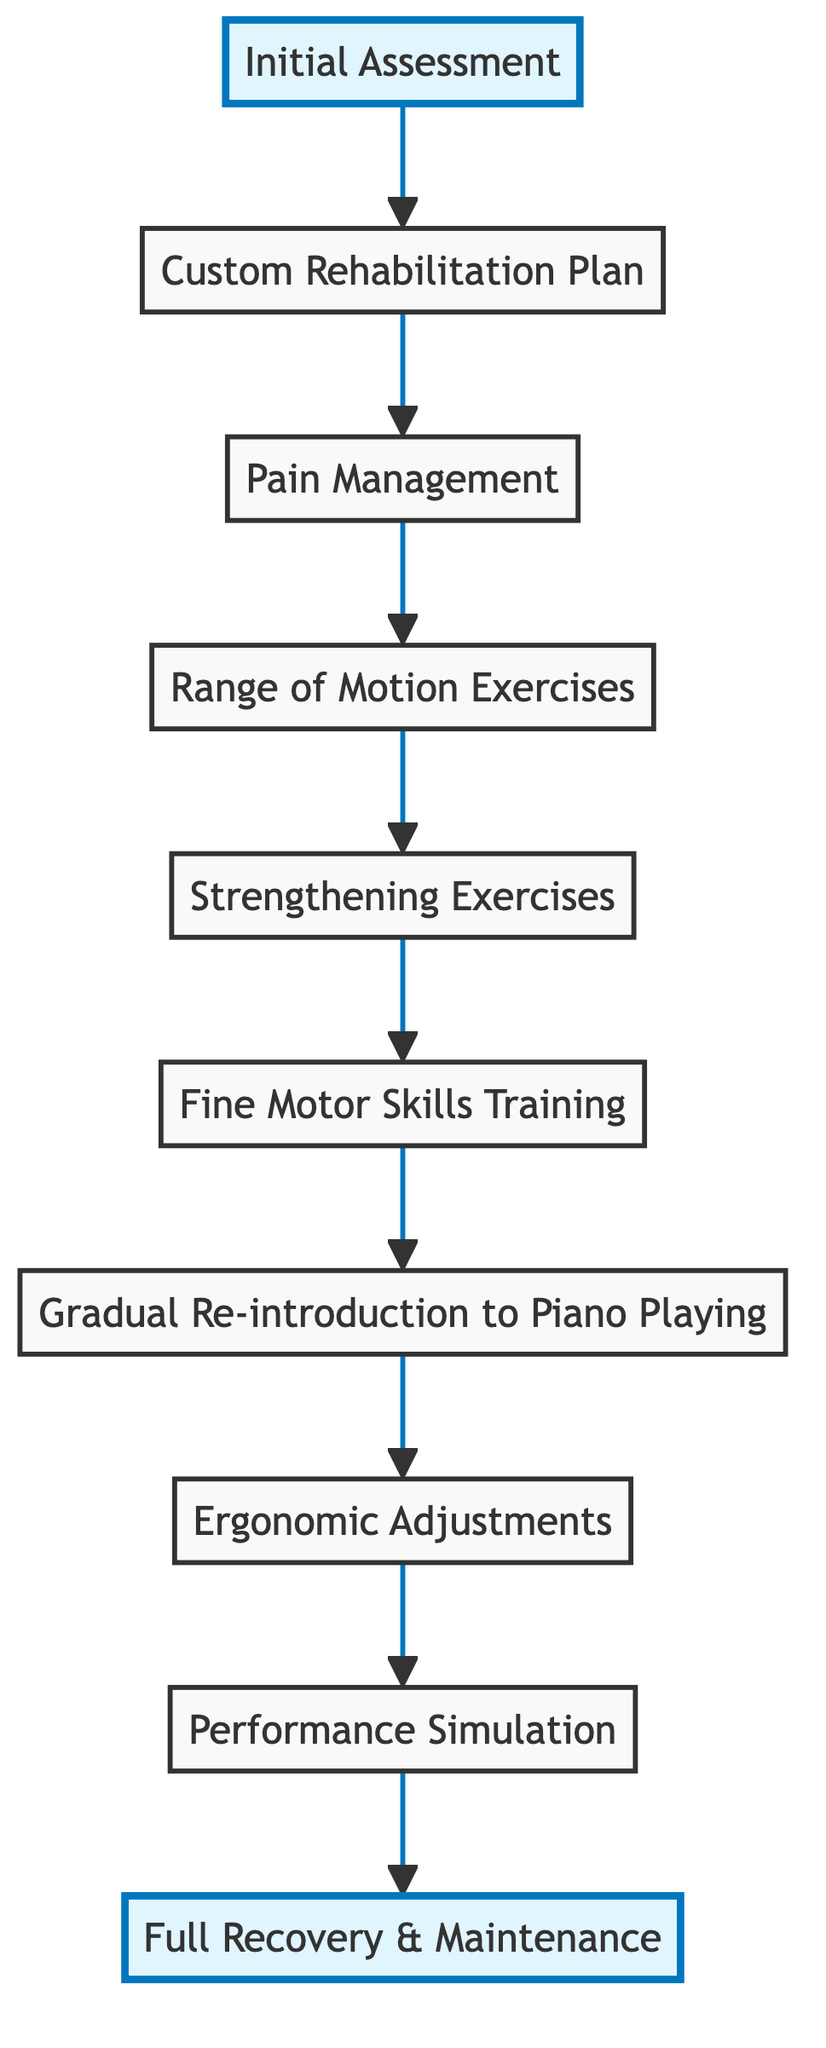What is the first step in the rehabilitation process? The first step in the flow chart is "Initial Assessment," which indicates the starting point of the rehabilitation process.
Answer: Initial Assessment How many steps are there in the rehabilitation process? By counting the nodes in the diagram, there are a total of 10 steps from the initial assessment to full recovery and maintenance.
Answer: 10 What is the last step in the rehabilitation process? The last step in the flow chart is "Full Recovery & Maintenance," which signifies the goal of the rehabilitation process.
Answer: Full Recovery & Maintenance Which step follows "Fine Motor Skills Training"? The step that follows "Fine Motor Skills Training" is "Gradual Re-introduction to Piano Playing," indicating a progression in the rehabilitation process.
Answer: Gradual Re-introduction to Piano Playing What type of exercises are focused on improving flexibility? The type of exercises aimed at improving flexibility are "Range of Motion Exercises," which are specifically designed to enhance joint movement.
Answer: Range of Motion Exercises How are pain management methods utilized in the rehabilitation process? Pain management methods, which include medication and gentle stretching, are utilized right after the custom rehabilitation plan to help mitigate pain during recovery.
Answer: After Custom Rehabilitation Plan What step comes before "Gradual Re-introduction to Piano Playing"? The step that comes before "Gradual Re-introduction to Piano Playing" is "Fine Motor Skills Training," indicating that coordination and dexterity are developed prior to piano practice.
Answer: Fine Motor Skills Training Which step involves ergonomic adjustments? The step involving ergonomic adjustments is "Ergonomic Adjustments," which focuses on preventing re-injury by modifying playing posture and technique.
Answer: Ergonomic Adjustments What is indicated by the upward direction of the flow chart? The upward direction of the flow chart indicates a progression towards recovery, suggesting that each step builds upon the previous one towards the final goal.
Answer: Progression towards recovery 